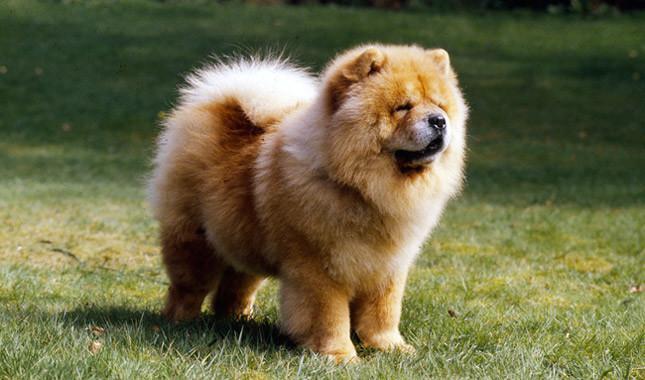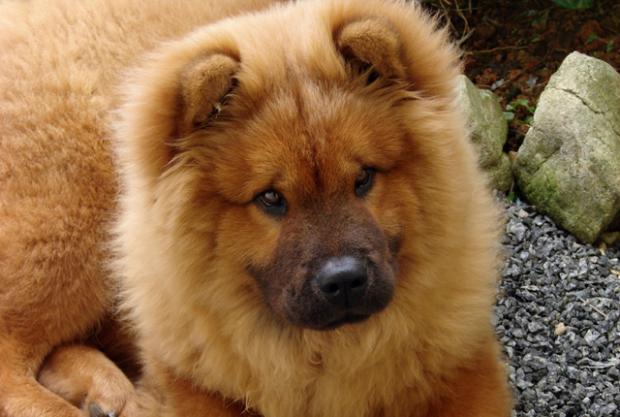The first image is the image on the left, the second image is the image on the right. Analyze the images presented: Is the assertion "The left image is a of a single dog standing on grass facing right." valid? Answer yes or no. Yes. The first image is the image on the left, the second image is the image on the right. Given the left and right images, does the statement "An image shows only one dog, which is standing on grass and has a closed mouth." hold true? Answer yes or no. Yes. 